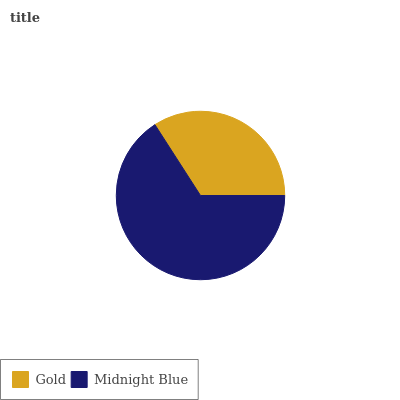Is Gold the minimum?
Answer yes or no. Yes. Is Midnight Blue the maximum?
Answer yes or no. Yes. Is Midnight Blue the minimum?
Answer yes or no. No. Is Midnight Blue greater than Gold?
Answer yes or no. Yes. Is Gold less than Midnight Blue?
Answer yes or no. Yes. Is Gold greater than Midnight Blue?
Answer yes or no. No. Is Midnight Blue less than Gold?
Answer yes or no. No. Is Midnight Blue the high median?
Answer yes or no. Yes. Is Gold the low median?
Answer yes or no. Yes. Is Gold the high median?
Answer yes or no. No. Is Midnight Blue the low median?
Answer yes or no. No. 